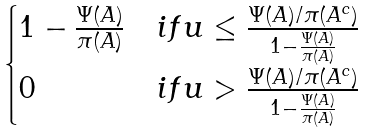Convert formula to latex. <formula><loc_0><loc_0><loc_500><loc_500>\begin{cases} 1 - \frac { \Psi ( A ) } { \pi ( A ) } & i f u \leq \frac { \Psi ( A ) / \pi ( A ^ { c } ) } { 1 - \frac { \Psi ( A ) } { \pi ( A ) } } \\ 0 & i f u > \frac { \Psi ( A ) / \pi ( A ^ { c } ) } { 1 - \frac { \Psi ( A ) } { \pi ( A ) } } \end{cases}</formula> 